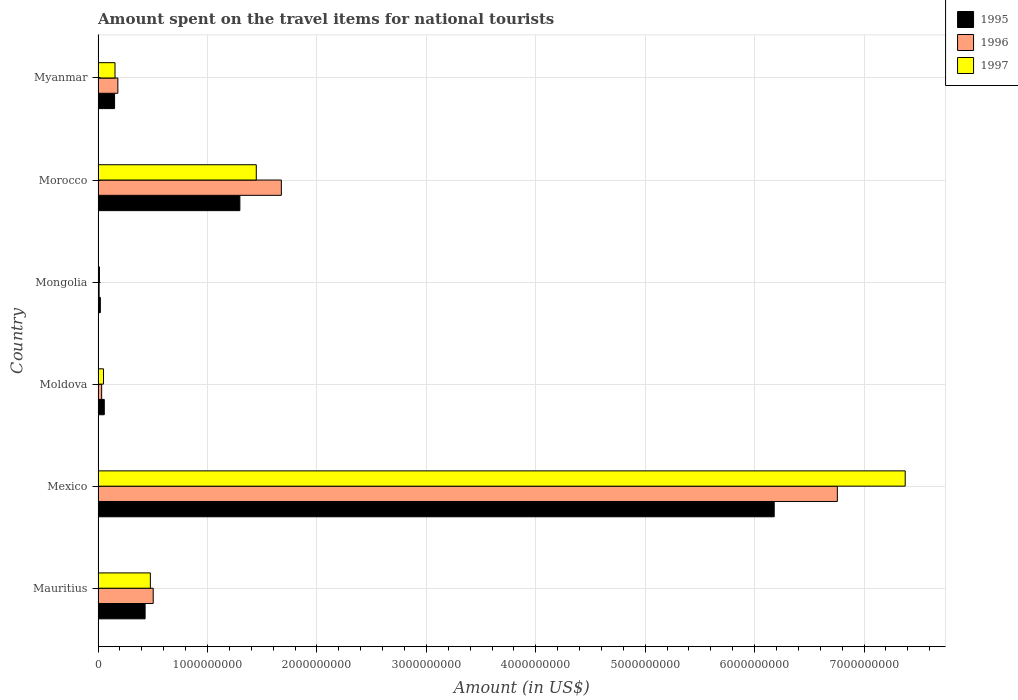How many different coloured bars are there?
Provide a succinct answer. 3. How many groups of bars are there?
Make the answer very short. 6. Are the number of bars per tick equal to the number of legend labels?
Provide a short and direct response. Yes. How many bars are there on the 2nd tick from the bottom?
Your answer should be very brief. 3. In how many cases, is the number of bars for a given country not equal to the number of legend labels?
Your answer should be very brief. 0. What is the amount spent on the travel items for national tourists in 1996 in Mexico?
Give a very brief answer. 6.76e+09. Across all countries, what is the maximum amount spent on the travel items for national tourists in 1995?
Keep it short and to the point. 6.18e+09. Across all countries, what is the minimum amount spent on the travel items for national tourists in 1997?
Keep it short and to the point. 1.30e+07. In which country was the amount spent on the travel items for national tourists in 1997 minimum?
Offer a very short reply. Mongolia. What is the total amount spent on the travel items for national tourists in 1995 in the graph?
Your answer should be compact. 8.13e+09. What is the difference between the amount spent on the travel items for national tourists in 1995 in Mauritius and that in Myanmar?
Your answer should be compact. 2.79e+08. What is the difference between the amount spent on the travel items for national tourists in 1996 in Myanmar and the amount spent on the travel items for national tourists in 1997 in Mongolia?
Give a very brief answer. 1.68e+08. What is the average amount spent on the travel items for national tourists in 1996 per country?
Your answer should be very brief. 1.53e+09. What is the difference between the amount spent on the travel items for national tourists in 1995 and amount spent on the travel items for national tourists in 1996 in Mexico?
Provide a short and direct response. -5.77e+08. In how many countries, is the amount spent on the travel items for national tourists in 1997 greater than 4200000000 US$?
Offer a very short reply. 1. What is the ratio of the amount spent on the travel items for national tourists in 1997 in Mongolia to that in Myanmar?
Your response must be concise. 0.08. Is the amount spent on the travel items for national tourists in 1997 in Mauritius less than that in Mexico?
Your answer should be compact. Yes. What is the difference between the highest and the second highest amount spent on the travel items for national tourists in 1996?
Offer a very short reply. 5.08e+09. What is the difference between the highest and the lowest amount spent on the travel items for national tourists in 1997?
Your answer should be compact. 7.36e+09. Is the sum of the amount spent on the travel items for national tourists in 1996 in Mexico and Moldova greater than the maximum amount spent on the travel items for national tourists in 1995 across all countries?
Offer a very short reply. Yes. How many bars are there?
Give a very brief answer. 18. Are all the bars in the graph horizontal?
Provide a short and direct response. Yes. How many countries are there in the graph?
Give a very brief answer. 6. Are the values on the major ticks of X-axis written in scientific E-notation?
Offer a terse response. No. Does the graph contain any zero values?
Your response must be concise. No. Does the graph contain grids?
Your response must be concise. Yes. Where does the legend appear in the graph?
Keep it short and to the point. Top right. What is the title of the graph?
Ensure brevity in your answer.  Amount spent on the travel items for national tourists. Does "1975" appear as one of the legend labels in the graph?
Keep it short and to the point. No. What is the Amount (in US$) of 1995 in Mauritius?
Your answer should be compact. 4.30e+08. What is the Amount (in US$) of 1996 in Mauritius?
Give a very brief answer. 5.04e+08. What is the Amount (in US$) in 1997 in Mauritius?
Offer a very short reply. 4.78e+08. What is the Amount (in US$) in 1995 in Mexico?
Offer a very short reply. 6.18e+09. What is the Amount (in US$) in 1996 in Mexico?
Provide a short and direct response. 6.76e+09. What is the Amount (in US$) in 1997 in Mexico?
Keep it short and to the point. 7.38e+09. What is the Amount (in US$) of 1995 in Moldova?
Provide a short and direct response. 5.70e+07. What is the Amount (in US$) of 1996 in Moldova?
Make the answer very short. 3.30e+07. What is the Amount (in US$) of 1997 in Moldova?
Give a very brief answer. 5.00e+07. What is the Amount (in US$) of 1995 in Mongolia?
Offer a terse response. 2.10e+07. What is the Amount (in US$) of 1996 in Mongolia?
Offer a terse response. 1.00e+07. What is the Amount (in US$) of 1997 in Mongolia?
Ensure brevity in your answer.  1.30e+07. What is the Amount (in US$) of 1995 in Morocco?
Provide a succinct answer. 1.30e+09. What is the Amount (in US$) in 1996 in Morocco?
Ensure brevity in your answer.  1.68e+09. What is the Amount (in US$) in 1997 in Morocco?
Provide a succinct answer. 1.45e+09. What is the Amount (in US$) in 1995 in Myanmar?
Provide a short and direct response. 1.51e+08. What is the Amount (in US$) in 1996 in Myanmar?
Your answer should be very brief. 1.81e+08. What is the Amount (in US$) in 1997 in Myanmar?
Give a very brief answer. 1.55e+08. Across all countries, what is the maximum Amount (in US$) in 1995?
Make the answer very short. 6.18e+09. Across all countries, what is the maximum Amount (in US$) in 1996?
Ensure brevity in your answer.  6.76e+09. Across all countries, what is the maximum Amount (in US$) in 1997?
Give a very brief answer. 7.38e+09. Across all countries, what is the minimum Amount (in US$) of 1995?
Make the answer very short. 2.10e+07. Across all countries, what is the minimum Amount (in US$) in 1997?
Provide a short and direct response. 1.30e+07. What is the total Amount (in US$) in 1995 in the graph?
Give a very brief answer. 8.13e+09. What is the total Amount (in US$) of 1996 in the graph?
Provide a short and direct response. 9.16e+09. What is the total Amount (in US$) of 1997 in the graph?
Provide a short and direct response. 9.52e+09. What is the difference between the Amount (in US$) of 1995 in Mauritius and that in Mexico?
Offer a terse response. -5.75e+09. What is the difference between the Amount (in US$) of 1996 in Mauritius and that in Mexico?
Offer a terse response. -6.25e+09. What is the difference between the Amount (in US$) in 1997 in Mauritius and that in Mexico?
Offer a terse response. -6.90e+09. What is the difference between the Amount (in US$) of 1995 in Mauritius and that in Moldova?
Give a very brief answer. 3.73e+08. What is the difference between the Amount (in US$) in 1996 in Mauritius and that in Moldova?
Provide a succinct answer. 4.71e+08. What is the difference between the Amount (in US$) of 1997 in Mauritius and that in Moldova?
Offer a very short reply. 4.28e+08. What is the difference between the Amount (in US$) of 1995 in Mauritius and that in Mongolia?
Offer a terse response. 4.09e+08. What is the difference between the Amount (in US$) of 1996 in Mauritius and that in Mongolia?
Provide a succinct answer. 4.94e+08. What is the difference between the Amount (in US$) in 1997 in Mauritius and that in Mongolia?
Offer a terse response. 4.65e+08. What is the difference between the Amount (in US$) in 1995 in Mauritius and that in Morocco?
Your response must be concise. -8.66e+08. What is the difference between the Amount (in US$) of 1996 in Mauritius and that in Morocco?
Make the answer very short. -1.17e+09. What is the difference between the Amount (in US$) in 1997 in Mauritius and that in Morocco?
Make the answer very short. -9.68e+08. What is the difference between the Amount (in US$) in 1995 in Mauritius and that in Myanmar?
Offer a very short reply. 2.79e+08. What is the difference between the Amount (in US$) of 1996 in Mauritius and that in Myanmar?
Ensure brevity in your answer.  3.23e+08. What is the difference between the Amount (in US$) of 1997 in Mauritius and that in Myanmar?
Give a very brief answer. 3.23e+08. What is the difference between the Amount (in US$) of 1995 in Mexico and that in Moldova?
Provide a short and direct response. 6.12e+09. What is the difference between the Amount (in US$) in 1996 in Mexico and that in Moldova?
Your answer should be very brief. 6.72e+09. What is the difference between the Amount (in US$) of 1997 in Mexico and that in Moldova?
Ensure brevity in your answer.  7.33e+09. What is the difference between the Amount (in US$) in 1995 in Mexico and that in Mongolia?
Offer a terse response. 6.16e+09. What is the difference between the Amount (in US$) in 1996 in Mexico and that in Mongolia?
Keep it short and to the point. 6.75e+09. What is the difference between the Amount (in US$) in 1997 in Mexico and that in Mongolia?
Offer a very short reply. 7.36e+09. What is the difference between the Amount (in US$) of 1995 in Mexico and that in Morocco?
Provide a short and direct response. 4.88e+09. What is the difference between the Amount (in US$) in 1996 in Mexico and that in Morocco?
Give a very brief answer. 5.08e+09. What is the difference between the Amount (in US$) of 1997 in Mexico and that in Morocco?
Your response must be concise. 5.93e+09. What is the difference between the Amount (in US$) in 1995 in Mexico and that in Myanmar?
Keep it short and to the point. 6.03e+09. What is the difference between the Amount (in US$) in 1996 in Mexico and that in Myanmar?
Ensure brevity in your answer.  6.58e+09. What is the difference between the Amount (in US$) of 1997 in Mexico and that in Myanmar?
Your answer should be very brief. 7.22e+09. What is the difference between the Amount (in US$) of 1995 in Moldova and that in Mongolia?
Keep it short and to the point. 3.60e+07. What is the difference between the Amount (in US$) in 1996 in Moldova and that in Mongolia?
Make the answer very short. 2.30e+07. What is the difference between the Amount (in US$) in 1997 in Moldova and that in Mongolia?
Your answer should be compact. 3.70e+07. What is the difference between the Amount (in US$) in 1995 in Moldova and that in Morocco?
Keep it short and to the point. -1.24e+09. What is the difference between the Amount (in US$) in 1996 in Moldova and that in Morocco?
Offer a very short reply. -1.64e+09. What is the difference between the Amount (in US$) in 1997 in Moldova and that in Morocco?
Provide a succinct answer. -1.40e+09. What is the difference between the Amount (in US$) of 1995 in Moldova and that in Myanmar?
Provide a short and direct response. -9.40e+07. What is the difference between the Amount (in US$) of 1996 in Moldova and that in Myanmar?
Keep it short and to the point. -1.48e+08. What is the difference between the Amount (in US$) in 1997 in Moldova and that in Myanmar?
Your answer should be very brief. -1.05e+08. What is the difference between the Amount (in US$) in 1995 in Mongolia and that in Morocco?
Your answer should be compact. -1.28e+09. What is the difference between the Amount (in US$) of 1996 in Mongolia and that in Morocco?
Make the answer very short. -1.66e+09. What is the difference between the Amount (in US$) of 1997 in Mongolia and that in Morocco?
Provide a short and direct response. -1.43e+09. What is the difference between the Amount (in US$) in 1995 in Mongolia and that in Myanmar?
Keep it short and to the point. -1.30e+08. What is the difference between the Amount (in US$) in 1996 in Mongolia and that in Myanmar?
Give a very brief answer. -1.71e+08. What is the difference between the Amount (in US$) of 1997 in Mongolia and that in Myanmar?
Provide a short and direct response. -1.42e+08. What is the difference between the Amount (in US$) in 1995 in Morocco and that in Myanmar?
Offer a terse response. 1.14e+09. What is the difference between the Amount (in US$) in 1996 in Morocco and that in Myanmar?
Your response must be concise. 1.49e+09. What is the difference between the Amount (in US$) in 1997 in Morocco and that in Myanmar?
Your response must be concise. 1.29e+09. What is the difference between the Amount (in US$) of 1995 in Mauritius and the Amount (in US$) of 1996 in Mexico?
Your response must be concise. -6.33e+09. What is the difference between the Amount (in US$) in 1995 in Mauritius and the Amount (in US$) in 1997 in Mexico?
Give a very brief answer. -6.95e+09. What is the difference between the Amount (in US$) in 1996 in Mauritius and the Amount (in US$) in 1997 in Mexico?
Make the answer very short. -6.87e+09. What is the difference between the Amount (in US$) of 1995 in Mauritius and the Amount (in US$) of 1996 in Moldova?
Provide a succinct answer. 3.97e+08. What is the difference between the Amount (in US$) of 1995 in Mauritius and the Amount (in US$) of 1997 in Moldova?
Your answer should be very brief. 3.80e+08. What is the difference between the Amount (in US$) of 1996 in Mauritius and the Amount (in US$) of 1997 in Moldova?
Make the answer very short. 4.54e+08. What is the difference between the Amount (in US$) in 1995 in Mauritius and the Amount (in US$) in 1996 in Mongolia?
Your answer should be compact. 4.20e+08. What is the difference between the Amount (in US$) in 1995 in Mauritius and the Amount (in US$) in 1997 in Mongolia?
Make the answer very short. 4.17e+08. What is the difference between the Amount (in US$) in 1996 in Mauritius and the Amount (in US$) in 1997 in Mongolia?
Keep it short and to the point. 4.91e+08. What is the difference between the Amount (in US$) in 1995 in Mauritius and the Amount (in US$) in 1996 in Morocco?
Keep it short and to the point. -1.24e+09. What is the difference between the Amount (in US$) of 1995 in Mauritius and the Amount (in US$) of 1997 in Morocco?
Your answer should be compact. -1.02e+09. What is the difference between the Amount (in US$) in 1996 in Mauritius and the Amount (in US$) in 1997 in Morocco?
Your answer should be compact. -9.42e+08. What is the difference between the Amount (in US$) of 1995 in Mauritius and the Amount (in US$) of 1996 in Myanmar?
Keep it short and to the point. 2.49e+08. What is the difference between the Amount (in US$) of 1995 in Mauritius and the Amount (in US$) of 1997 in Myanmar?
Keep it short and to the point. 2.75e+08. What is the difference between the Amount (in US$) of 1996 in Mauritius and the Amount (in US$) of 1997 in Myanmar?
Your answer should be very brief. 3.49e+08. What is the difference between the Amount (in US$) in 1995 in Mexico and the Amount (in US$) in 1996 in Moldova?
Offer a very short reply. 6.15e+09. What is the difference between the Amount (in US$) of 1995 in Mexico and the Amount (in US$) of 1997 in Moldova?
Your response must be concise. 6.13e+09. What is the difference between the Amount (in US$) of 1996 in Mexico and the Amount (in US$) of 1997 in Moldova?
Make the answer very short. 6.71e+09. What is the difference between the Amount (in US$) of 1995 in Mexico and the Amount (in US$) of 1996 in Mongolia?
Give a very brief answer. 6.17e+09. What is the difference between the Amount (in US$) of 1995 in Mexico and the Amount (in US$) of 1997 in Mongolia?
Your response must be concise. 6.17e+09. What is the difference between the Amount (in US$) of 1996 in Mexico and the Amount (in US$) of 1997 in Mongolia?
Offer a very short reply. 6.74e+09. What is the difference between the Amount (in US$) in 1995 in Mexico and the Amount (in US$) in 1996 in Morocco?
Give a very brief answer. 4.50e+09. What is the difference between the Amount (in US$) in 1995 in Mexico and the Amount (in US$) in 1997 in Morocco?
Your answer should be compact. 4.73e+09. What is the difference between the Amount (in US$) of 1996 in Mexico and the Amount (in US$) of 1997 in Morocco?
Offer a terse response. 5.31e+09. What is the difference between the Amount (in US$) in 1995 in Mexico and the Amount (in US$) in 1996 in Myanmar?
Offer a very short reply. 6.00e+09. What is the difference between the Amount (in US$) in 1995 in Mexico and the Amount (in US$) in 1997 in Myanmar?
Offer a terse response. 6.02e+09. What is the difference between the Amount (in US$) of 1996 in Mexico and the Amount (in US$) of 1997 in Myanmar?
Offer a terse response. 6.60e+09. What is the difference between the Amount (in US$) in 1995 in Moldova and the Amount (in US$) in 1996 in Mongolia?
Your answer should be compact. 4.70e+07. What is the difference between the Amount (in US$) in 1995 in Moldova and the Amount (in US$) in 1997 in Mongolia?
Provide a succinct answer. 4.40e+07. What is the difference between the Amount (in US$) of 1996 in Moldova and the Amount (in US$) of 1997 in Mongolia?
Make the answer very short. 2.00e+07. What is the difference between the Amount (in US$) in 1995 in Moldova and the Amount (in US$) in 1996 in Morocco?
Your response must be concise. -1.62e+09. What is the difference between the Amount (in US$) of 1995 in Moldova and the Amount (in US$) of 1997 in Morocco?
Your response must be concise. -1.39e+09. What is the difference between the Amount (in US$) in 1996 in Moldova and the Amount (in US$) in 1997 in Morocco?
Your answer should be very brief. -1.41e+09. What is the difference between the Amount (in US$) of 1995 in Moldova and the Amount (in US$) of 1996 in Myanmar?
Ensure brevity in your answer.  -1.24e+08. What is the difference between the Amount (in US$) of 1995 in Moldova and the Amount (in US$) of 1997 in Myanmar?
Provide a short and direct response. -9.80e+07. What is the difference between the Amount (in US$) of 1996 in Moldova and the Amount (in US$) of 1997 in Myanmar?
Make the answer very short. -1.22e+08. What is the difference between the Amount (in US$) in 1995 in Mongolia and the Amount (in US$) in 1996 in Morocco?
Offer a terse response. -1.65e+09. What is the difference between the Amount (in US$) in 1995 in Mongolia and the Amount (in US$) in 1997 in Morocco?
Your response must be concise. -1.42e+09. What is the difference between the Amount (in US$) of 1996 in Mongolia and the Amount (in US$) of 1997 in Morocco?
Your answer should be compact. -1.44e+09. What is the difference between the Amount (in US$) of 1995 in Mongolia and the Amount (in US$) of 1996 in Myanmar?
Your response must be concise. -1.60e+08. What is the difference between the Amount (in US$) in 1995 in Mongolia and the Amount (in US$) in 1997 in Myanmar?
Offer a very short reply. -1.34e+08. What is the difference between the Amount (in US$) of 1996 in Mongolia and the Amount (in US$) of 1997 in Myanmar?
Ensure brevity in your answer.  -1.45e+08. What is the difference between the Amount (in US$) of 1995 in Morocco and the Amount (in US$) of 1996 in Myanmar?
Give a very brief answer. 1.12e+09. What is the difference between the Amount (in US$) in 1995 in Morocco and the Amount (in US$) in 1997 in Myanmar?
Give a very brief answer. 1.14e+09. What is the difference between the Amount (in US$) of 1996 in Morocco and the Amount (in US$) of 1997 in Myanmar?
Provide a short and direct response. 1.52e+09. What is the average Amount (in US$) of 1995 per country?
Your answer should be very brief. 1.36e+09. What is the average Amount (in US$) of 1996 per country?
Give a very brief answer. 1.53e+09. What is the average Amount (in US$) of 1997 per country?
Make the answer very short. 1.59e+09. What is the difference between the Amount (in US$) in 1995 and Amount (in US$) in 1996 in Mauritius?
Make the answer very short. -7.40e+07. What is the difference between the Amount (in US$) in 1995 and Amount (in US$) in 1997 in Mauritius?
Your response must be concise. -4.80e+07. What is the difference between the Amount (in US$) in 1996 and Amount (in US$) in 1997 in Mauritius?
Offer a terse response. 2.60e+07. What is the difference between the Amount (in US$) in 1995 and Amount (in US$) in 1996 in Mexico?
Provide a succinct answer. -5.77e+08. What is the difference between the Amount (in US$) of 1995 and Amount (in US$) of 1997 in Mexico?
Ensure brevity in your answer.  -1.20e+09. What is the difference between the Amount (in US$) of 1996 and Amount (in US$) of 1997 in Mexico?
Make the answer very short. -6.20e+08. What is the difference between the Amount (in US$) of 1995 and Amount (in US$) of 1996 in Moldova?
Ensure brevity in your answer.  2.40e+07. What is the difference between the Amount (in US$) of 1995 and Amount (in US$) of 1997 in Moldova?
Give a very brief answer. 7.00e+06. What is the difference between the Amount (in US$) of 1996 and Amount (in US$) of 1997 in Moldova?
Your answer should be compact. -1.70e+07. What is the difference between the Amount (in US$) in 1995 and Amount (in US$) in 1996 in Mongolia?
Your answer should be compact. 1.10e+07. What is the difference between the Amount (in US$) in 1996 and Amount (in US$) in 1997 in Mongolia?
Your answer should be compact. -3.00e+06. What is the difference between the Amount (in US$) of 1995 and Amount (in US$) of 1996 in Morocco?
Offer a very short reply. -3.79e+08. What is the difference between the Amount (in US$) in 1995 and Amount (in US$) in 1997 in Morocco?
Offer a terse response. -1.50e+08. What is the difference between the Amount (in US$) in 1996 and Amount (in US$) in 1997 in Morocco?
Offer a very short reply. 2.29e+08. What is the difference between the Amount (in US$) of 1995 and Amount (in US$) of 1996 in Myanmar?
Your answer should be compact. -3.00e+07. What is the difference between the Amount (in US$) of 1996 and Amount (in US$) of 1997 in Myanmar?
Offer a terse response. 2.60e+07. What is the ratio of the Amount (in US$) of 1995 in Mauritius to that in Mexico?
Ensure brevity in your answer.  0.07. What is the ratio of the Amount (in US$) in 1996 in Mauritius to that in Mexico?
Ensure brevity in your answer.  0.07. What is the ratio of the Amount (in US$) in 1997 in Mauritius to that in Mexico?
Your answer should be compact. 0.06. What is the ratio of the Amount (in US$) of 1995 in Mauritius to that in Moldova?
Your answer should be compact. 7.54. What is the ratio of the Amount (in US$) of 1996 in Mauritius to that in Moldova?
Offer a very short reply. 15.27. What is the ratio of the Amount (in US$) of 1997 in Mauritius to that in Moldova?
Make the answer very short. 9.56. What is the ratio of the Amount (in US$) of 1995 in Mauritius to that in Mongolia?
Provide a succinct answer. 20.48. What is the ratio of the Amount (in US$) of 1996 in Mauritius to that in Mongolia?
Your response must be concise. 50.4. What is the ratio of the Amount (in US$) in 1997 in Mauritius to that in Mongolia?
Provide a short and direct response. 36.77. What is the ratio of the Amount (in US$) in 1995 in Mauritius to that in Morocco?
Provide a succinct answer. 0.33. What is the ratio of the Amount (in US$) in 1996 in Mauritius to that in Morocco?
Your response must be concise. 0.3. What is the ratio of the Amount (in US$) in 1997 in Mauritius to that in Morocco?
Your answer should be compact. 0.33. What is the ratio of the Amount (in US$) in 1995 in Mauritius to that in Myanmar?
Your answer should be very brief. 2.85. What is the ratio of the Amount (in US$) in 1996 in Mauritius to that in Myanmar?
Offer a terse response. 2.78. What is the ratio of the Amount (in US$) in 1997 in Mauritius to that in Myanmar?
Your answer should be very brief. 3.08. What is the ratio of the Amount (in US$) in 1995 in Mexico to that in Moldova?
Offer a terse response. 108.4. What is the ratio of the Amount (in US$) of 1996 in Mexico to that in Moldova?
Your answer should be compact. 204.73. What is the ratio of the Amount (in US$) of 1997 in Mexico to that in Moldova?
Make the answer very short. 147.52. What is the ratio of the Amount (in US$) in 1995 in Mexico to that in Mongolia?
Your response must be concise. 294.24. What is the ratio of the Amount (in US$) in 1996 in Mexico to that in Mongolia?
Your response must be concise. 675.6. What is the ratio of the Amount (in US$) of 1997 in Mexico to that in Mongolia?
Provide a short and direct response. 567.38. What is the ratio of the Amount (in US$) in 1995 in Mexico to that in Morocco?
Your response must be concise. 4.77. What is the ratio of the Amount (in US$) of 1996 in Mexico to that in Morocco?
Make the answer very short. 4.03. What is the ratio of the Amount (in US$) of 1997 in Mexico to that in Morocco?
Make the answer very short. 5.1. What is the ratio of the Amount (in US$) in 1995 in Mexico to that in Myanmar?
Provide a succinct answer. 40.92. What is the ratio of the Amount (in US$) in 1996 in Mexico to that in Myanmar?
Keep it short and to the point. 37.33. What is the ratio of the Amount (in US$) of 1997 in Mexico to that in Myanmar?
Ensure brevity in your answer.  47.59. What is the ratio of the Amount (in US$) of 1995 in Moldova to that in Mongolia?
Your response must be concise. 2.71. What is the ratio of the Amount (in US$) of 1996 in Moldova to that in Mongolia?
Offer a terse response. 3.3. What is the ratio of the Amount (in US$) in 1997 in Moldova to that in Mongolia?
Keep it short and to the point. 3.85. What is the ratio of the Amount (in US$) in 1995 in Moldova to that in Morocco?
Ensure brevity in your answer.  0.04. What is the ratio of the Amount (in US$) in 1996 in Moldova to that in Morocco?
Provide a short and direct response. 0.02. What is the ratio of the Amount (in US$) of 1997 in Moldova to that in Morocco?
Your response must be concise. 0.03. What is the ratio of the Amount (in US$) of 1995 in Moldova to that in Myanmar?
Your answer should be very brief. 0.38. What is the ratio of the Amount (in US$) in 1996 in Moldova to that in Myanmar?
Your response must be concise. 0.18. What is the ratio of the Amount (in US$) in 1997 in Moldova to that in Myanmar?
Your answer should be very brief. 0.32. What is the ratio of the Amount (in US$) of 1995 in Mongolia to that in Morocco?
Provide a short and direct response. 0.02. What is the ratio of the Amount (in US$) in 1996 in Mongolia to that in Morocco?
Your response must be concise. 0.01. What is the ratio of the Amount (in US$) of 1997 in Mongolia to that in Morocco?
Make the answer very short. 0.01. What is the ratio of the Amount (in US$) in 1995 in Mongolia to that in Myanmar?
Your response must be concise. 0.14. What is the ratio of the Amount (in US$) of 1996 in Mongolia to that in Myanmar?
Offer a very short reply. 0.06. What is the ratio of the Amount (in US$) of 1997 in Mongolia to that in Myanmar?
Offer a very short reply. 0.08. What is the ratio of the Amount (in US$) in 1995 in Morocco to that in Myanmar?
Your answer should be very brief. 8.58. What is the ratio of the Amount (in US$) of 1996 in Morocco to that in Myanmar?
Keep it short and to the point. 9.25. What is the ratio of the Amount (in US$) of 1997 in Morocco to that in Myanmar?
Keep it short and to the point. 9.33. What is the difference between the highest and the second highest Amount (in US$) of 1995?
Offer a very short reply. 4.88e+09. What is the difference between the highest and the second highest Amount (in US$) in 1996?
Make the answer very short. 5.08e+09. What is the difference between the highest and the second highest Amount (in US$) in 1997?
Your answer should be very brief. 5.93e+09. What is the difference between the highest and the lowest Amount (in US$) in 1995?
Keep it short and to the point. 6.16e+09. What is the difference between the highest and the lowest Amount (in US$) in 1996?
Provide a succinct answer. 6.75e+09. What is the difference between the highest and the lowest Amount (in US$) in 1997?
Make the answer very short. 7.36e+09. 